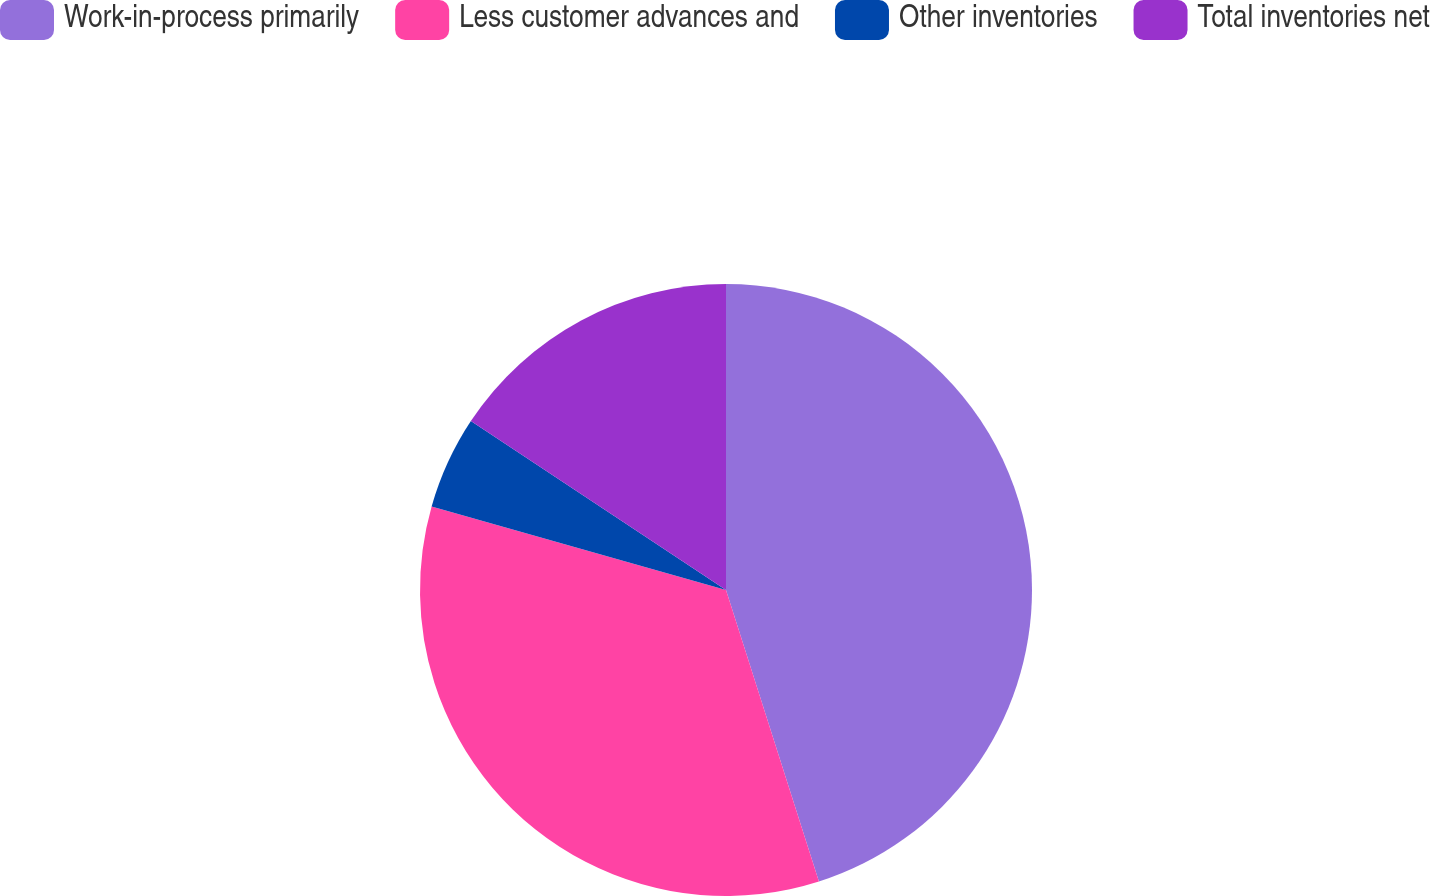Convert chart to OTSL. <chart><loc_0><loc_0><loc_500><loc_500><pie_chart><fcel>Work-in-process primarily<fcel>Less customer advances and<fcel>Other inventories<fcel>Total inventories net<nl><fcel>45.09%<fcel>34.31%<fcel>4.91%<fcel>15.69%<nl></chart> 